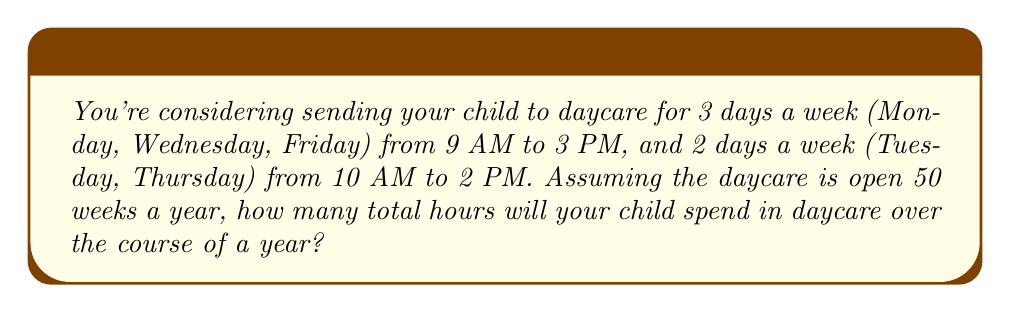Solve this math problem. Let's break this down step-by-step:

1. Calculate hours per day for 3-day schedule:
   $$(3 \text{ PM} - 9 \text{ AM}) = 6 \text{ hours}$$

2. Calculate hours per day for 2-day schedule:
   $$(2 \text{ PM} - 10 \text{ AM}) = 4 \text{ hours}$$

3. Calculate total hours per week:
   $$3 \text{ days} \times 6 \text{ hours} + 2 \text{ days} \times 4 \text{ hours} = 18 + 8 = 26 \text{ hours}$$

4. Calculate total hours per year:
   $$26 \text{ hours per week} \times 50 \text{ weeks} = 1300 \text{ hours}$$

Therefore, your child will spend 1300 hours in daycare over the course of a year.
Answer: 1300 hours 